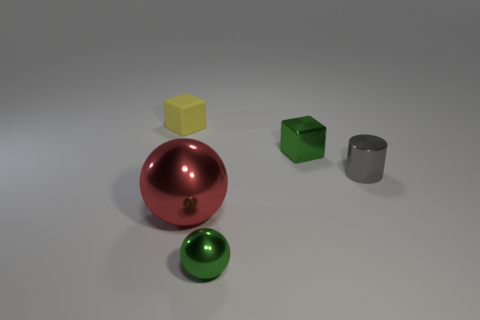Is there any other thing that is the same material as the yellow cube?
Ensure brevity in your answer.  No. There is a green object behind the green thing in front of the big red shiny ball; what shape is it?
Your answer should be compact. Cube. What color is the other shiny object that is the same shape as the large shiny object?
Ensure brevity in your answer.  Green. There is a shiny object that is behind the gray metallic cylinder; is it the same size as the large metal thing?
Give a very brief answer. No. What shape is the tiny thing that is the same color as the small metal ball?
Provide a short and direct response. Cube. What number of small green objects have the same material as the cylinder?
Offer a very short reply. 2. There is a small block that is on the right side of the small block that is on the left side of the small green metal object in front of the tiny green block; what is its material?
Offer a terse response. Metal. The cube that is to the left of the small green thing in front of the metallic cube is what color?
Your answer should be compact. Yellow. What color is the cylinder that is the same size as the yellow thing?
Offer a terse response. Gray. What number of small objects are either shiny objects or metallic spheres?
Your answer should be very brief. 3. 